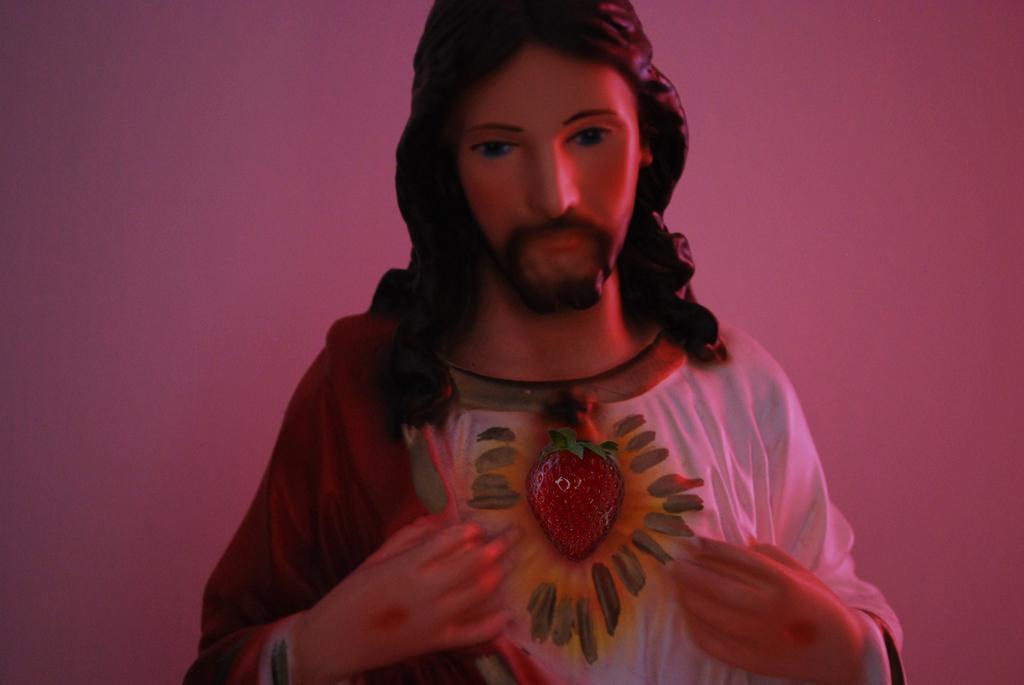Please provide a concise description of this image. There is a statue of a Jesus Christ and the background is pink in color. 